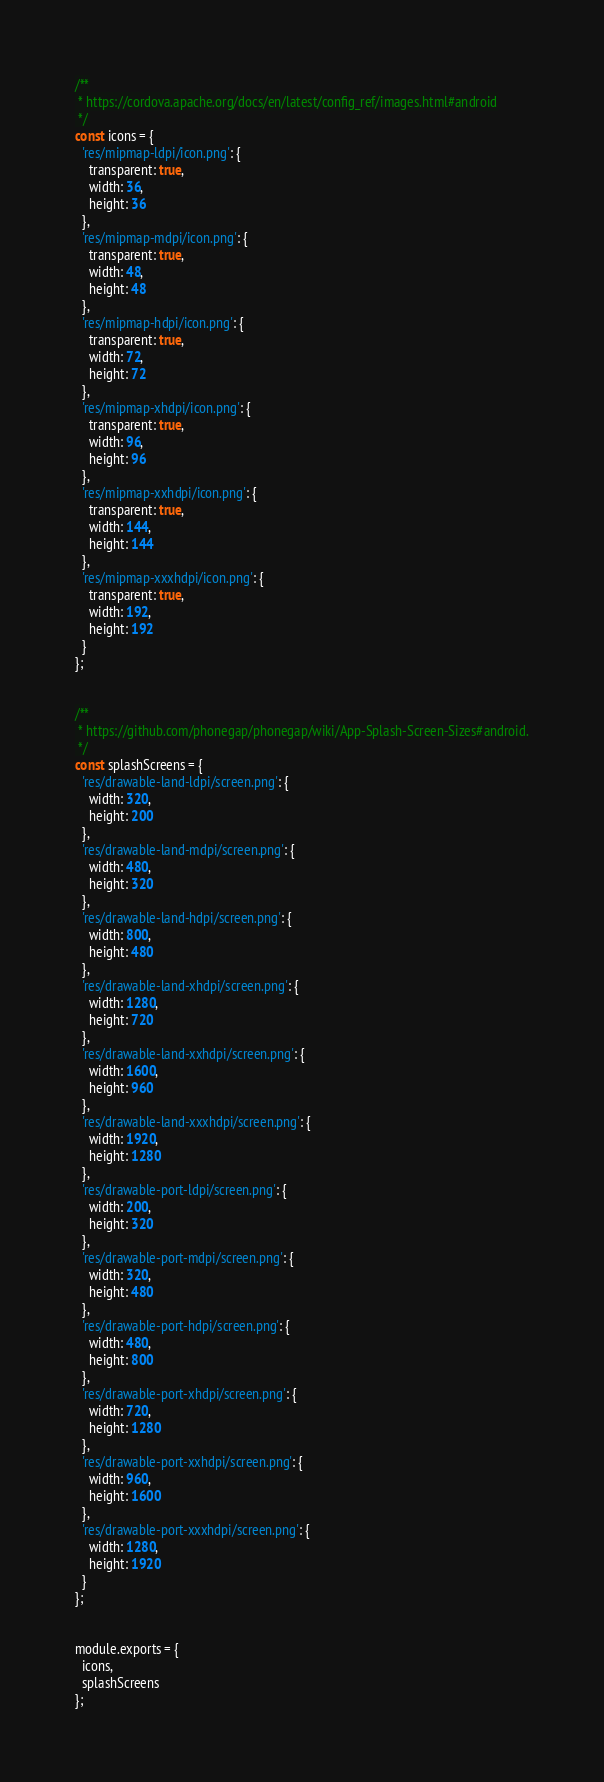<code> <loc_0><loc_0><loc_500><loc_500><_JavaScript_>/**
 * https://cordova.apache.org/docs/en/latest/config_ref/images.html#android
 */
const icons = {
  'res/mipmap-ldpi/icon.png': {
    transparent: true,
    width: 36,
    height: 36
  },
  'res/mipmap-mdpi/icon.png': {
    transparent: true,
    width: 48,
    height: 48
  },
  'res/mipmap-hdpi/icon.png': {
    transparent: true,
    width: 72,
    height: 72
  },
  'res/mipmap-xhdpi/icon.png': {
    transparent: true,
    width: 96,
    height: 96
  },
  'res/mipmap-xxhdpi/icon.png': {
    transparent: true,
    width: 144,
    height: 144
  },
  'res/mipmap-xxxhdpi/icon.png': {
    transparent: true,
    width: 192,
    height: 192
  }
};


/**
 * https://github.com/phonegap/phonegap/wiki/App-Splash-Screen-Sizes#android.
 */
const splashScreens = {
  'res/drawable-land-ldpi/screen.png': {
    width: 320,
    height: 200
  },
  'res/drawable-land-mdpi/screen.png': {
    width: 480,
    height: 320
  },
  'res/drawable-land-hdpi/screen.png': {
    width: 800,
    height: 480
  },
  'res/drawable-land-xhdpi/screen.png': {
    width: 1280,
    height: 720
  },
  'res/drawable-land-xxhdpi/screen.png': {
    width: 1600,
    height: 960
  },
  'res/drawable-land-xxxhdpi/screen.png': {
    width: 1920,
    height: 1280
  },
  'res/drawable-port-ldpi/screen.png': {
    width: 200,
    height: 320
  },
  'res/drawable-port-mdpi/screen.png': {
    width: 320,
    height: 480
  },
  'res/drawable-port-hdpi/screen.png': {
    width: 480,
    height: 800
  },
  'res/drawable-port-xhdpi/screen.png': {
    width: 720,
    height: 1280
  },
  'res/drawable-port-xxhdpi/screen.png': {
    width: 960,
    height: 1600
  },
  'res/drawable-port-xxxhdpi/screen.png': {
    width: 1280,
    height: 1920
  }
};


module.exports = {
  icons,
  splashScreens
};
</code> 